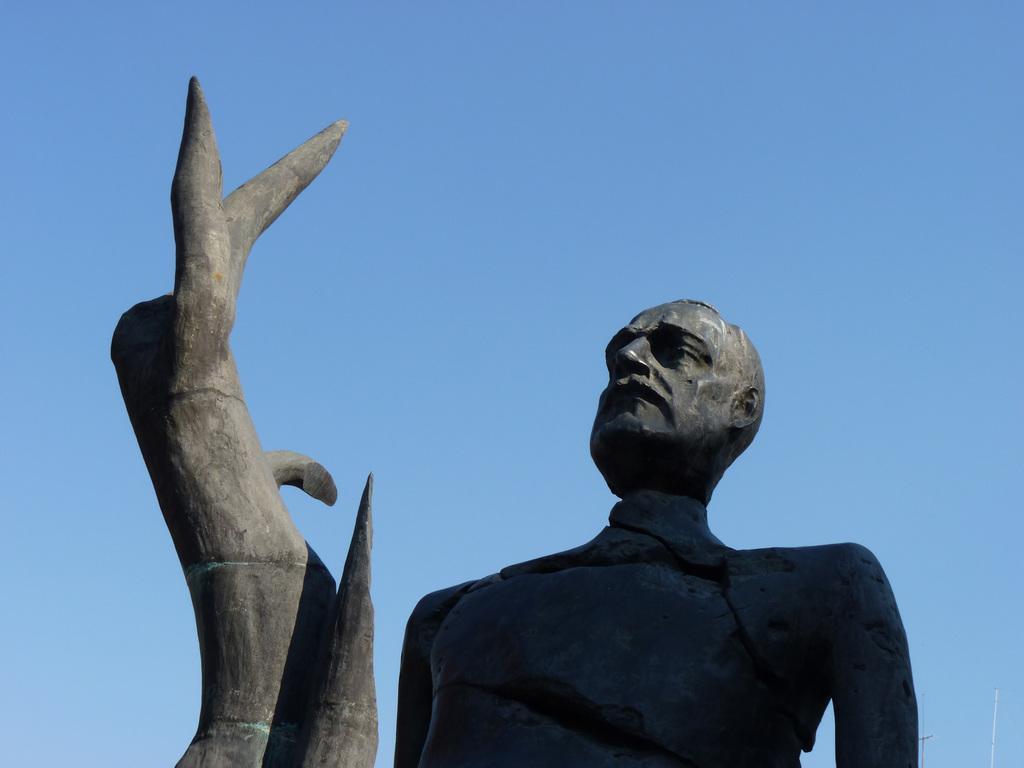Can you describe this image briefly? In front of the image there is a statue of a person and also there is an object. Behind the statue there is sky.  